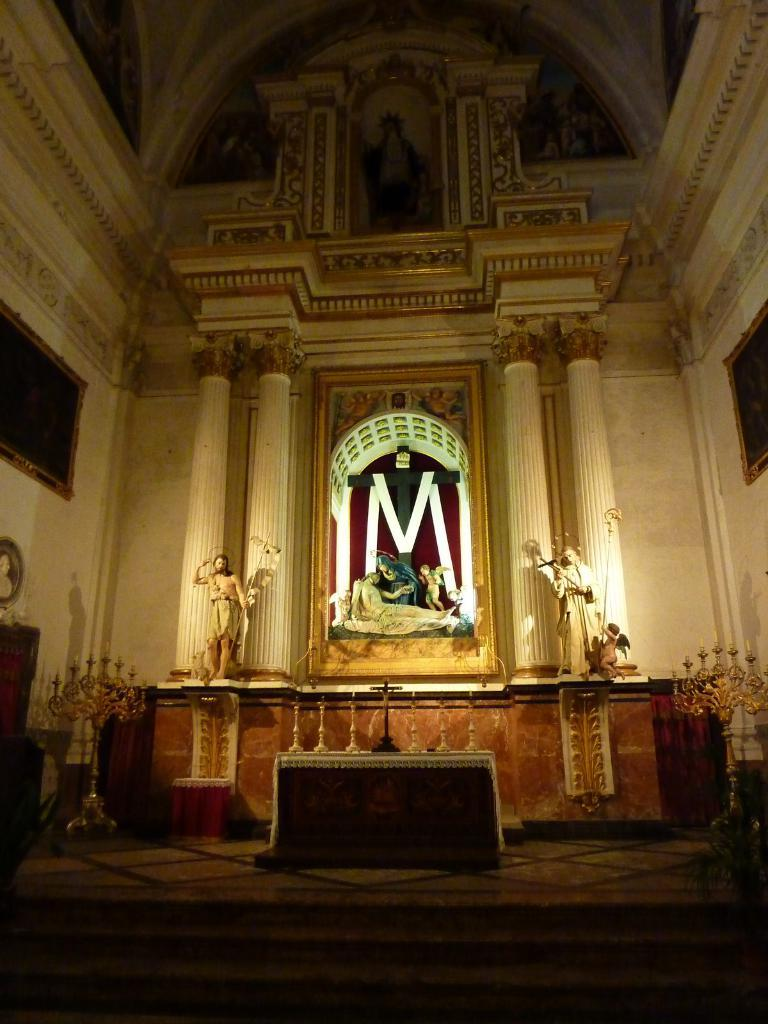What part of a building can be seen in the image? The image shows the inner part of a building. What decorative elements are visible in the image? There are statues visible in the image. What architectural feature is present in the image? Pillars are present in the image. What color is the wall in the image? The wall in the image is cream-colored. What type of drum can be heard playing in the image? There is no drum present in the image, and therefore no sound can be heard. 